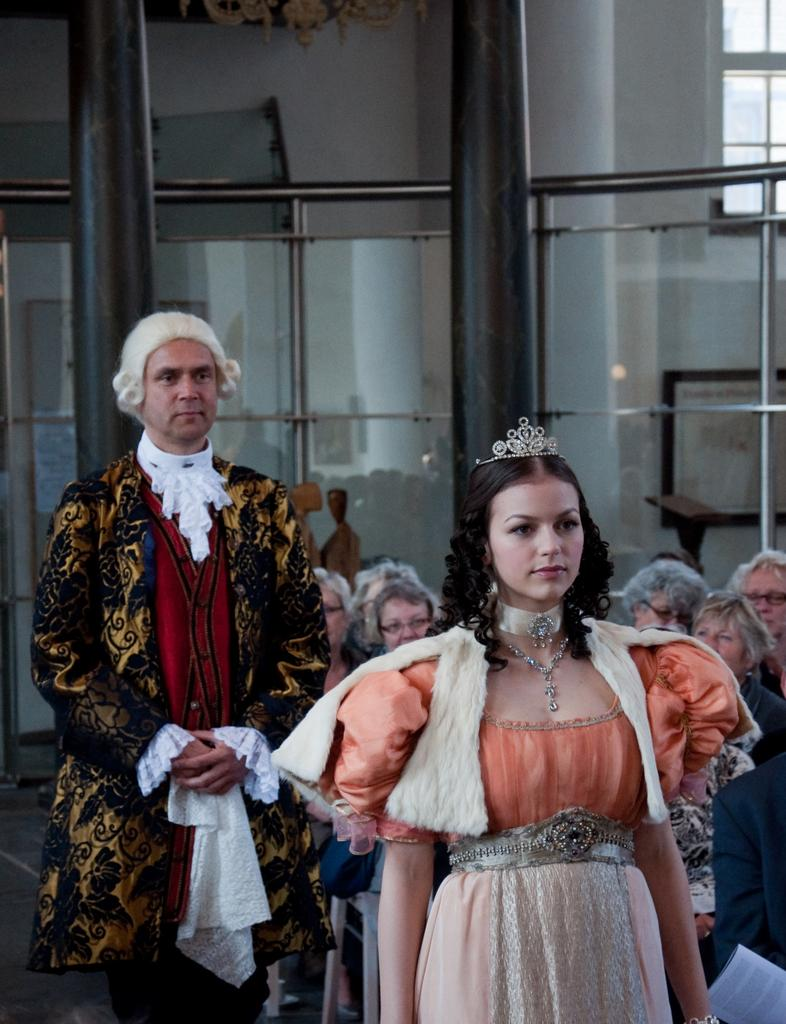How many people are present in the image? There are two people, a man and a woman, present in the image. What are the man and the woman wearing? Both the man and the woman are wearing costumes. What additional accessory is the woman wearing? The woman is wearing a crown. What can be seen in the background of the image? There are pillars and people in the background of the image. What type of car is the person driving in the image? There is no person driving a car in the image; it features a man and a woman wearing costumes and standing in front of pillars and people. 